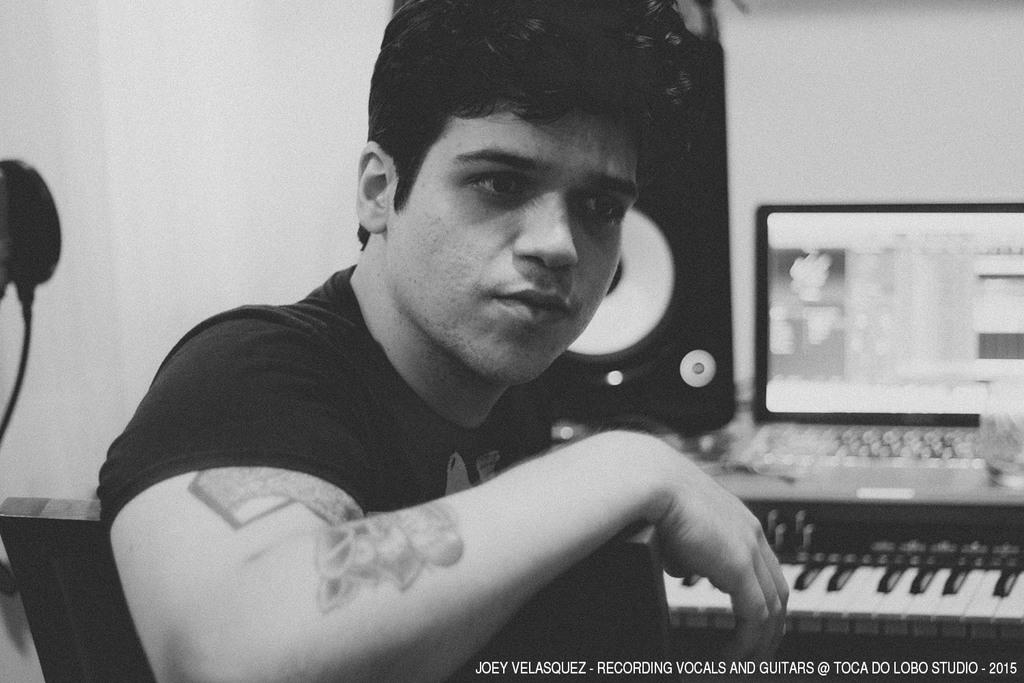What is there is a person sitting on a chair in the image, what is the person doing? The person is sitting on a chair in the image. What object is beside the person? There is a piano beside the person. What electronic device is present in the image? There is a laptop in the image. What is used for amplifying sound in the image? There are speakers in the image. What can be seen in the background of the image? There is a wall in the background of the image. How many cherries are on the piano in the image? There are no cherries present in the image, and the piano is not mentioned to have any cherries on it. 